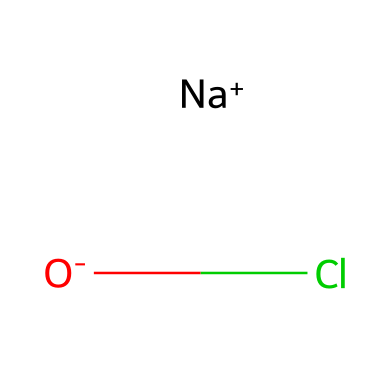What is the chemical name of the compound represented by this structure? The SMILES notation indicates the presence of sodium (Na), oxygen (O), and chlorine (Cl). Therefore, this compound is known as sodium hypochlorite.
Answer: sodium hypochlorite How many atoms are present in the chemical structure? The structure shows one sodium atom, one oxygen atom, and one chlorine atom, totaling three atoms.
Answer: three What is the oxidation state of chlorine in sodium hypochlorite? In sodium hypochlorite (NaOCl), sodium is +1 and oxygen is typically -2. Therefore, for the molecule to be neutral, chlorine must be +1.
Answer: +1 Which part of the chemical contributes to its disinfectant properties? The hypochlorite ion (OCl-) is known for its antimicrobial properties, making it effective as a disinfectant.
Answer: hypochlorite ion How many bonds are present in the sodium hypochlorite molecule? Sodium hypochlorite contains one ionic bond between sodium and oxygen and one covalent bond between oxygen and chlorine, making a total of two bonds.
Answer: two Is sodium hypochlorite considered a halogen compound? Yes, the presence of chlorine, which is a halogen, confirms that sodium hypochlorite is a halogen compound.
Answer: yes 